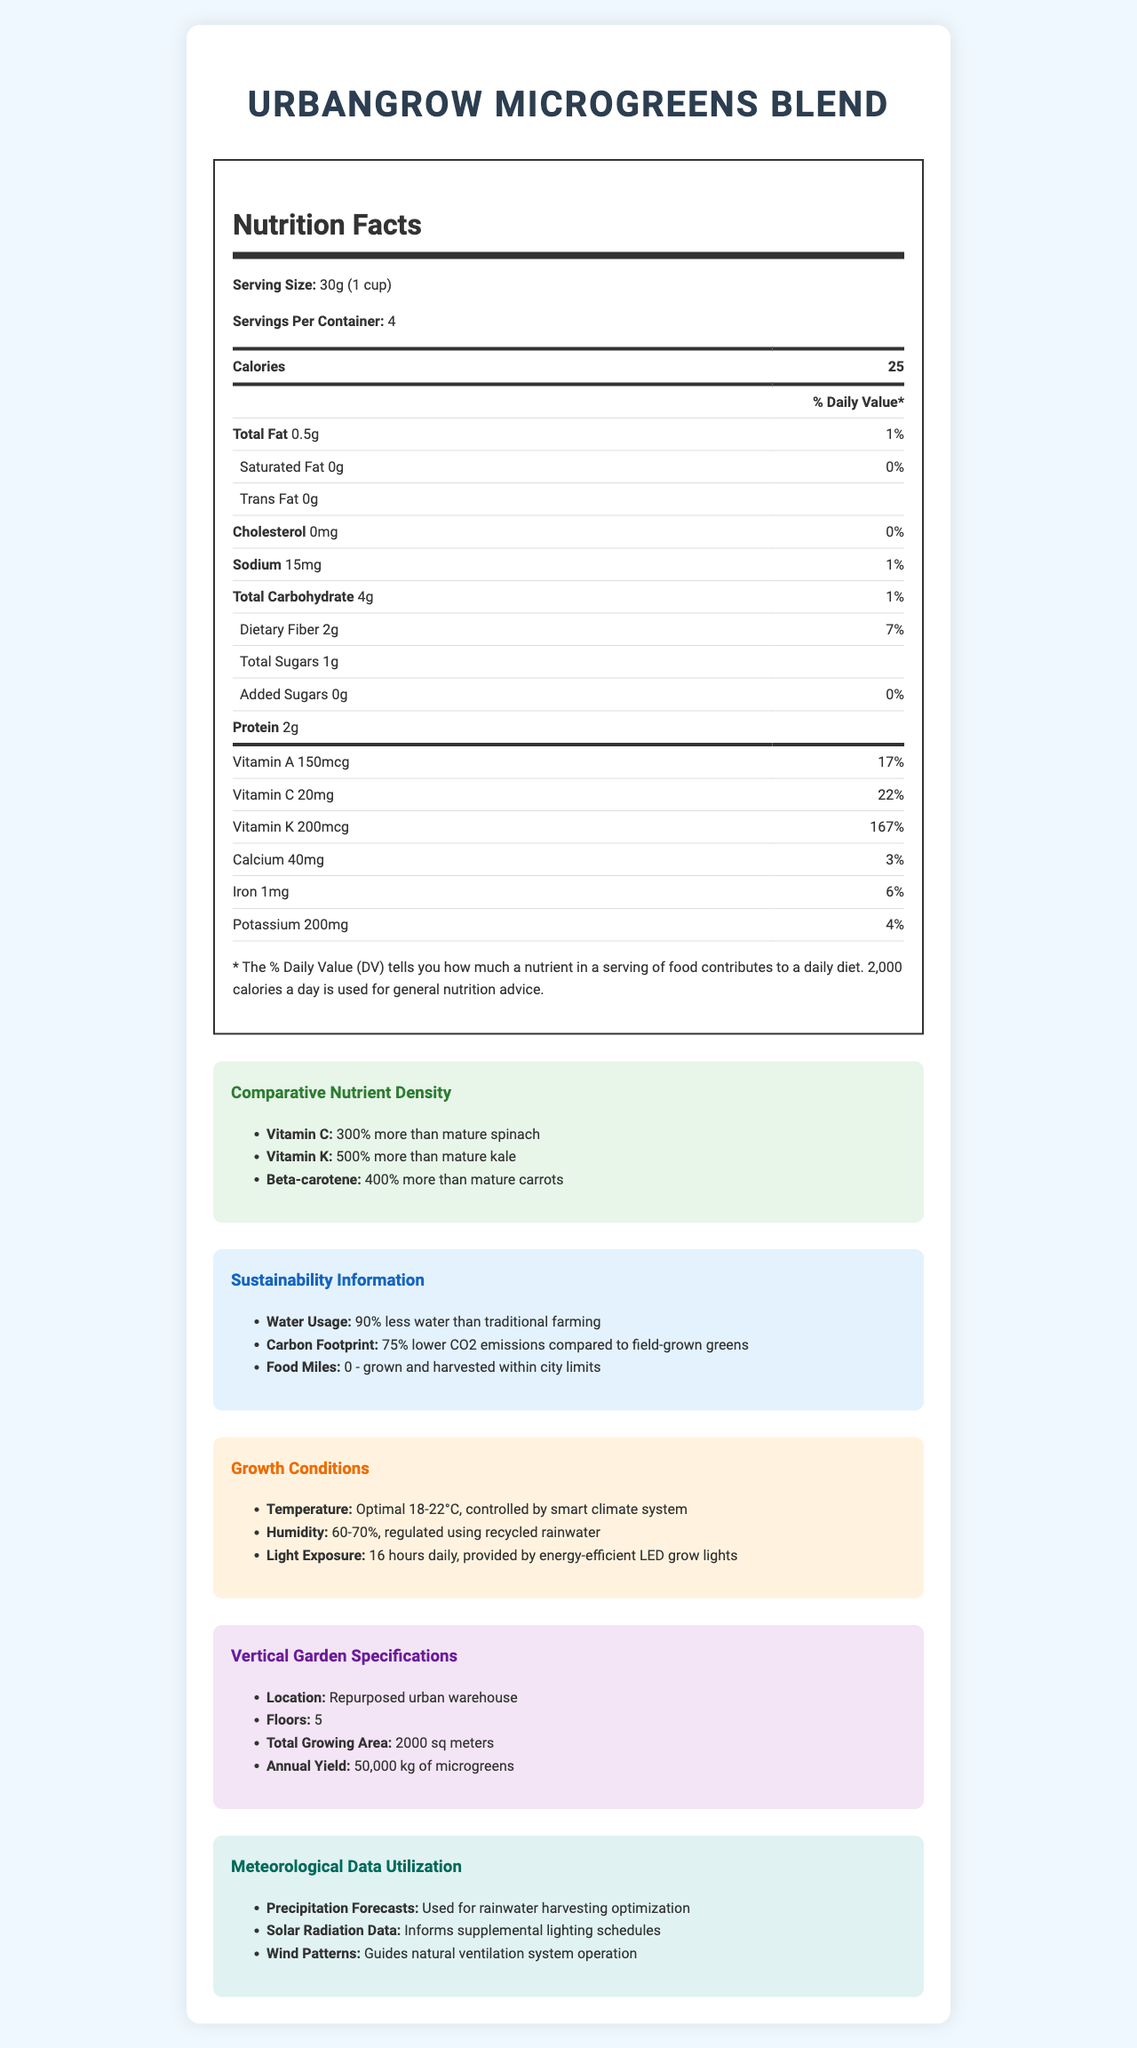how many calories are in one serving? The document states that each serving contains 25 calories.
Answer: 25 What is the % Daily Value of Vitamin C per serving? According to the nutrition facts in the document, each serving provides 22% of the Daily Value for Vitamin C.
Answer: 22% How much sodium is in one serving of UrbanGrow Microgreens Blend? The nutrition label indicates there are 15mg of sodium per serving.
Answer: 15mg What is the serving size for UrbanGrow Microgreens Blend? The document specifies that the serving size is 30g, which is equivalent to 1 cup.
Answer: 30g (1 cup) How much protein is present in each serving? The nutrition facts specify that each serving contains 2 grams of protein.
Answer: 2g Which of the following nutrients does UrbanGrow Microgreens Blend have 500% more of compared to mature kale?  
A. Vitamin C  
B. Vitamin K  
C. Beta-carotene The nutrient density section states that UrbanGrow Microgreens Blend has 500% more Vitamin K than mature kale.
Answer: B What is the total growing area of the vertical garden?  
I. 1000 sq meters  
II. 1500 sq meters  
III. 2000 sq meters The vertical garden specifications mention that the total growing area is 2000 sq meters.
Answer: III Does UrbanGrow Microgreens Blend use added sugars? The nutrition facts indicate 0g of added sugars per serving.
Answer: No Summarize the sustainability information for UrbanGrow Microgreens Blend. The sustainability section provides details on water usage, carbon footprint, and food miles.
Answer: UrbanGrow Microgreens Blend uses 90% less water than traditional farming, produces 75% lower CO2 emissions compared to field-grown greens, and has zero food miles as it is grown and harvested within city limits. Is the temperature for growing UrbanGrow Microgreens Blend controlled by a smart climate system? The growth conditions section specifies that the temperature is controlled by a smart climate system.
Answer: Yes What is the average daily light exposure for the microgreens? According to the growth conditions section, the microgreens receive 16 hours of light exposure daily from energy-efficient LED grow lights.
Answer: 16 hours How much more Beta-carotene do UrbanGrow Microgreens have compared to mature carrots? The comparative nutrient density section states that UrbanGrow Microgreens contain 400% more Beta-carotene than mature carrots.
Answer: 400% What is the location of the vertical garden where the microgreens are grown? The vertical garden specifications mention that it is located in a repurposed urban warehouse.
Answer: Repurposed urban warehouse What meteorological data is used to optimize rainwater harvesting? The meteorological data utilization section mentions that precipitation forecasts are used for optimizing rainwater harvesting.
Answer: Precipitation forecasts Which nutrient has the highest % Daily Value per serving? The nutrition facts indicate that Vitamin K has the highest % Daily Value per serving at 167%.
Answer: Vitamin K What is the exact percentage of water saved by UrbanGrow Microgreens Blend compared to traditional farming? The sustainability information section states that UrbanGrow Microgreens Blend uses 90% less water than traditional farming.
Answer: 90% How often are the wind patterns utilized for natural ventilation in the growth system? The document does not specify how often the wind patterns data is utilized for natural ventilation.
Answer: Cannot be determined What are the optimal temperature conditions for growing UrbanGrow Microgreens? The growth conditions section mentions that the optimal temperature for growing UrbanGrow Microgreens is 18-22°C.
Answer: 18-22°C 